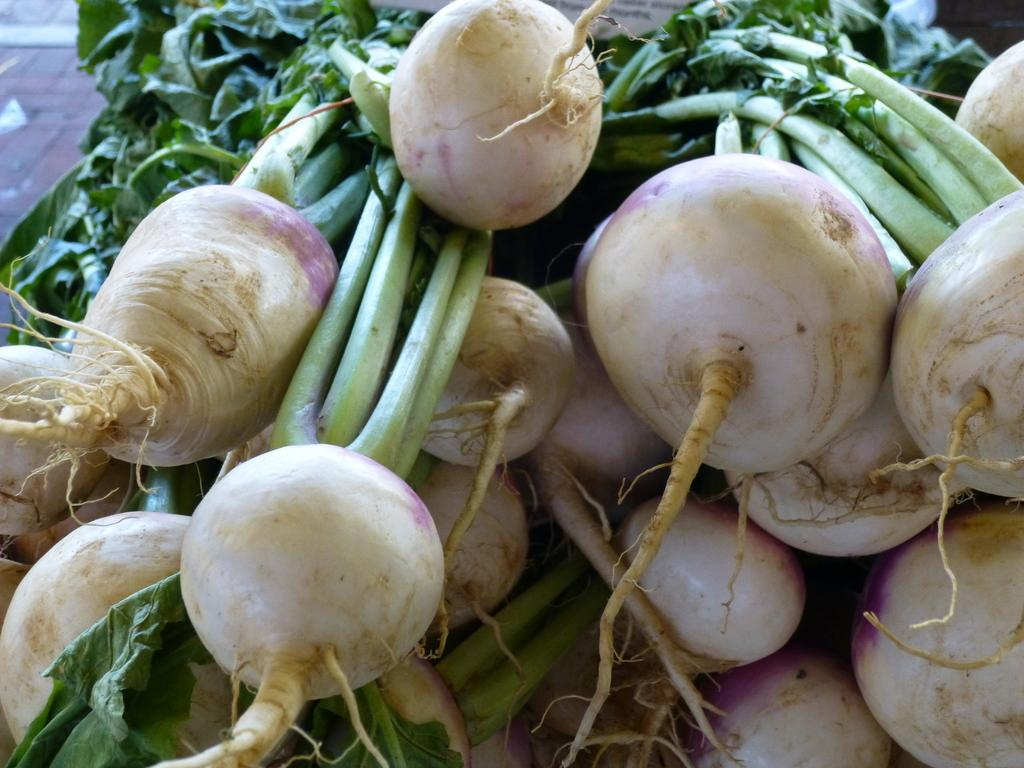What type of food items are visible in the image? There are vegetables in the image, including spinach. Can you describe the floor that is visible in the image? There is a floor on the left side of the image. Where is the hall located in the image? There is no hall present in the image. Can you tell me how many copies of the spinach are visible in the image? There is only one instance of spinach visible in the image, so the concept of "copies" does not apply. 